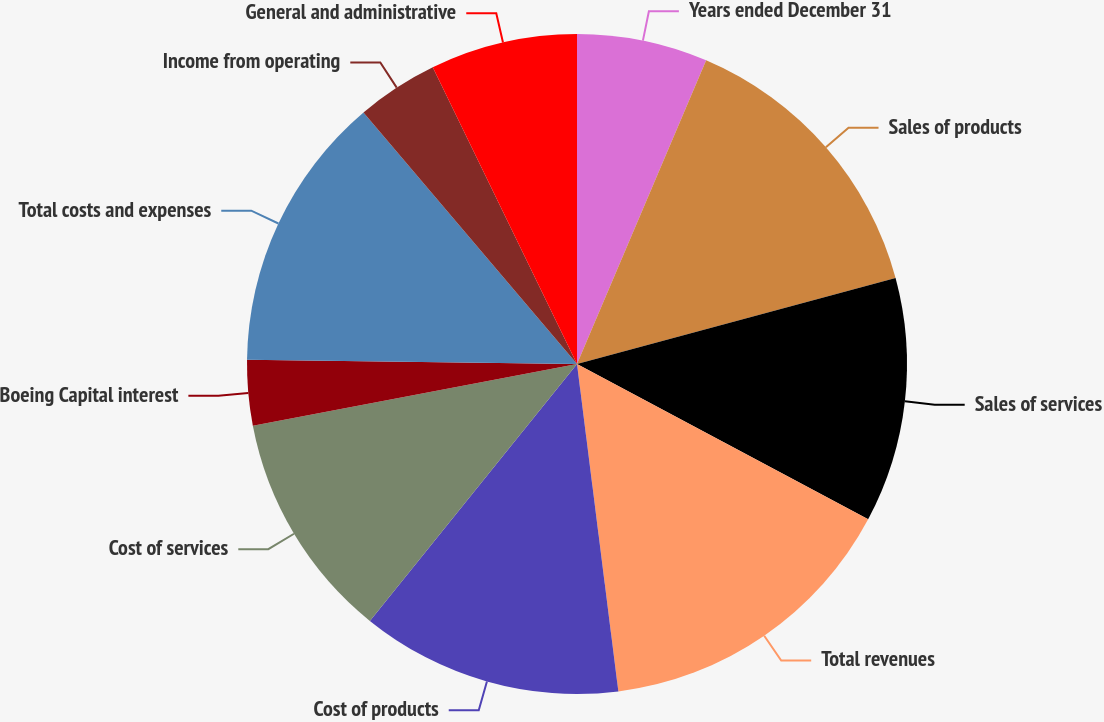Convert chart. <chart><loc_0><loc_0><loc_500><loc_500><pie_chart><fcel>Years ended December 31<fcel>Sales of products<fcel>Sales of services<fcel>Total revenues<fcel>Cost of products<fcel>Cost of services<fcel>Boeing Capital interest<fcel>Total costs and expenses<fcel>Income from operating<fcel>General and administrative<nl><fcel>6.4%<fcel>14.4%<fcel>12.0%<fcel>15.2%<fcel>12.8%<fcel>11.2%<fcel>3.2%<fcel>13.6%<fcel>4.0%<fcel>7.2%<nl></chart> 